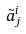<formula> <loc_0><loc_0><loc_500><loc_500>\tilde { a } _ { j } ^ { i }</formula> 